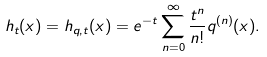<formula> <loc_0><loc_0><loc_500><loc_500>h _ { t } ( x ) = h _ { q , t } ( x ) = e ^ { - t } \sum _ { n = 0 } ^ { \infty } \frac { t ^ { n } } { n ! } q ^ { ( n ) } ( x ) .</formula> 